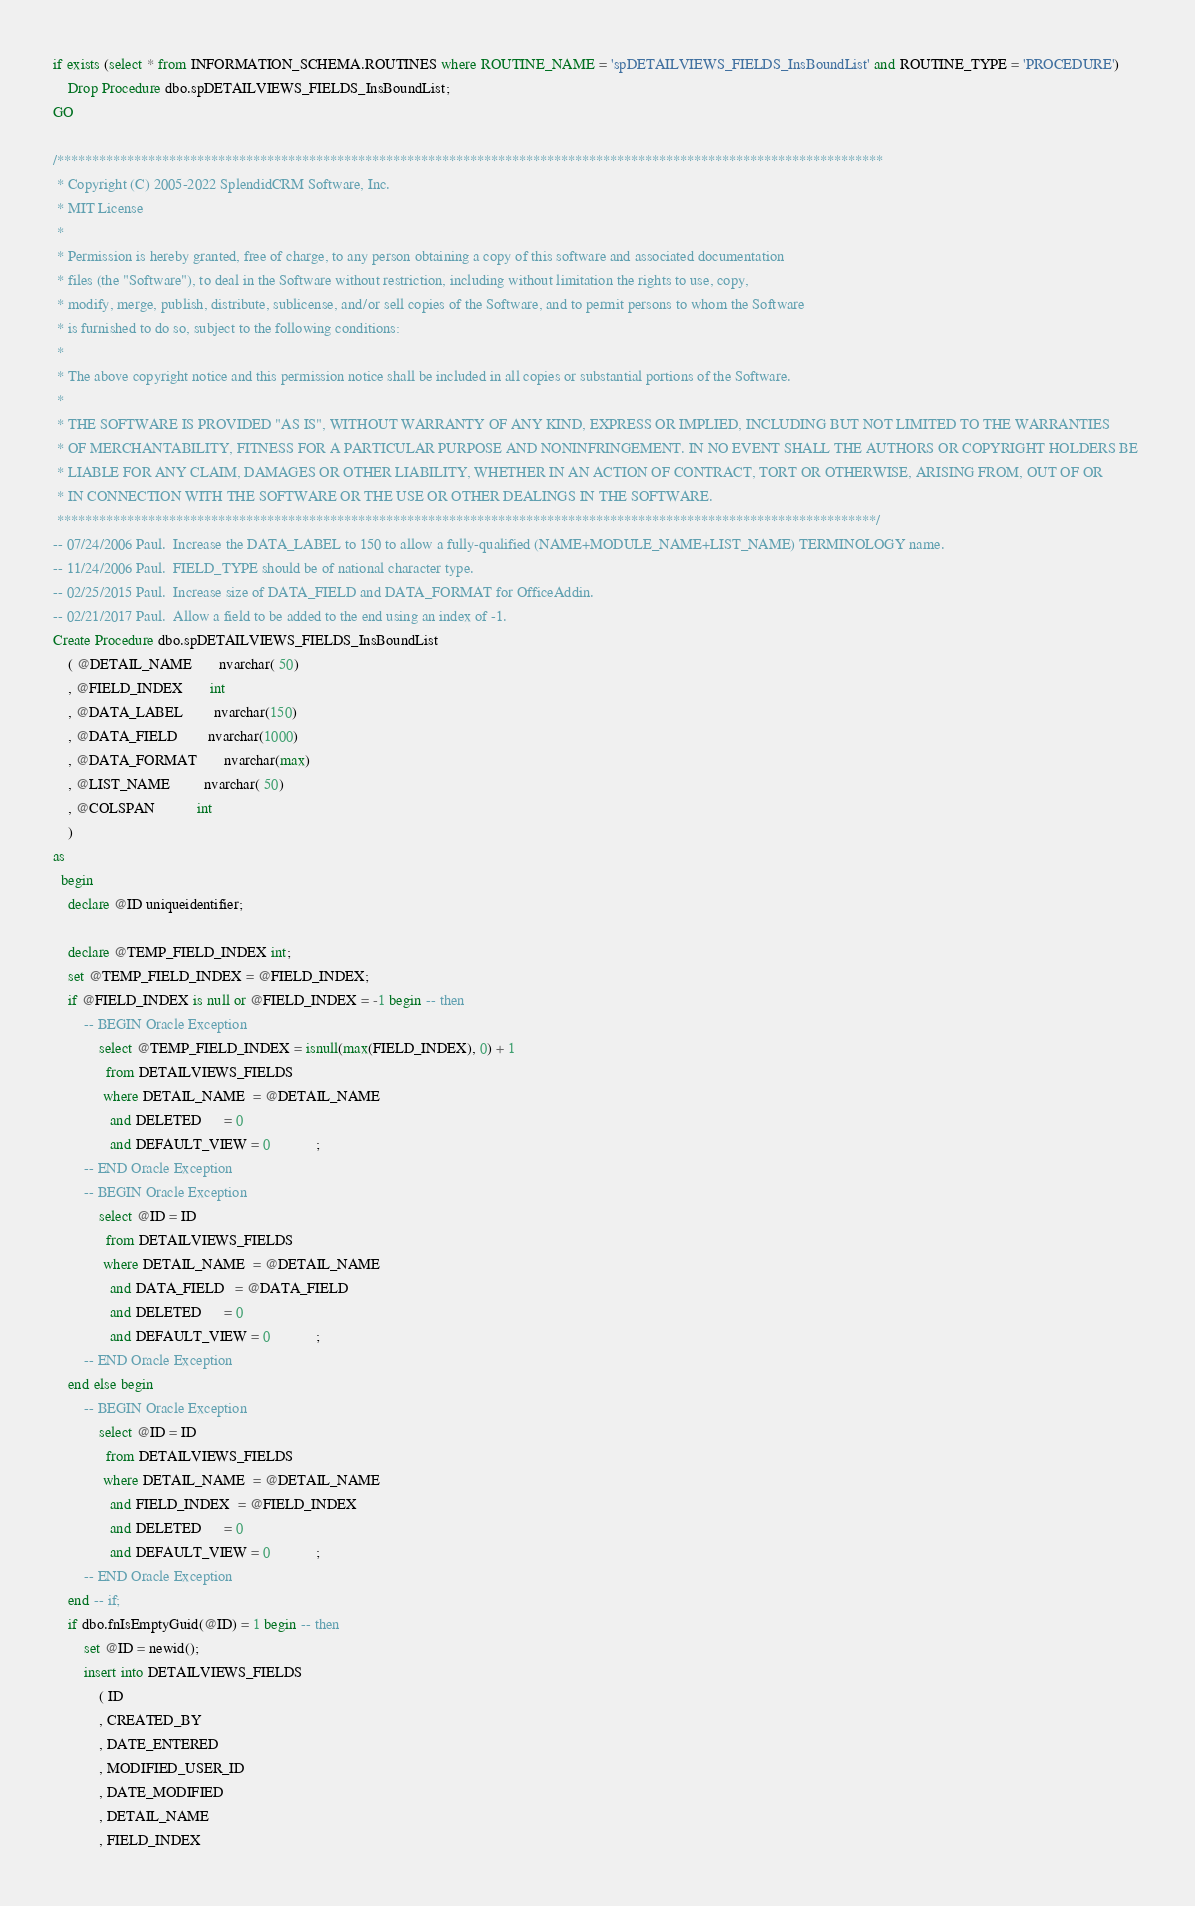<code> <loc_0><loc_0><loc_500><loc_500><_SQL_>if exists (select * from INFORMATION_SCHEMA.ROUTINES where ROUTINE_NAME = 'spDETAILVIEWS_FIELDS_InsBoundList' and ROUTINE_TYPE = 'PROCEDURE')
	Drop Procedure dbo.spDETAILVIEWS_FIELDS_InsBoundList;
GO
 
/**********************************************************************************************************************
 * Copyright (C) 2005-2022 SplendidCRM Software, Inc. 
 * MIT License
 * 
 * Permission is hereby granted, free of charge, to any person obtaining a copy of this software and associated documentation 
 * files (the "Software"), to deal in the Software without restriction, including without limitation the rights to use, copy, 
 * modify, merge, publish, distribute, sublicense, and/or sell copies of the Software, and to permit persons to whom the Software 
 * is furnished to do so, subject to the following conditions:
 * 
 * The above copyright notice and this permission notice shall be included in all copies or substantial portions of the Software.
 * 
 * THE SOFTWARE IS PROVIDED "AS IS", WITHOUT WARRANTY OF ANY KIND, EXPRESS OR IMPLIED, INCLUDING BUT NOT LIMITED TO THE WARRANTIES 
 * OF MERCHANTABILITY, FITNESS FOR A PARTICULAR PURPOSE AND NONINFRINGEMENT. IN NO EVENT SHALL THE AUTHORS OR COPYRIGHT HOLDERS BE 
 * LIABLE FOR ANY CLAIM, DAMAGES OR OTHER LIABILITY, WHETHER IN AN ACTION OF CONTRACT, TORT OR OTHERWISE, ARISING FROM, OUT OF OR 
 * IN CONNECTION WITH THE SOFTWARE OR THE USE OR OTHER DEALINGS IN THE SOFTWARE.
 *********************************************************************************************************************/
-- 07/24/2006 Paul.  Increase the DATA_LABEL to 150 to allow a fully-qualified (NAME+MODULE_NAME+LIST_NAME) TERMINOLOGY name. 
-- 11/24/2006 Paul.  FIELD_TYPE should be of national character type. 
-- 02/25/2015 Paul.  Increase size of DATA_FIELD and DATA_FORMAT for OfficeAddin. 
-- 02/21/2017 Paul.  Allow a field to be added to the end using an index of -1. 
Create Procedure dbo.spDETAILVIEWS_FIELDS_InsBoundList
	( @DETAIL_NAME       nvarchar( 50)
	, @FIELD_INDEX       int
	, @DATA_LABEL        nvarchar(150)
	, @DATA_FIELD        nvarchar(1000)
	, @DATA_FORMAT       nvarchar(max)
	, @LIST_NAME         nvarchar( 50)
	, @COLSPAN           int
	)
as
  begin
	declare @ID uniqueidentifier;
	
	declare @TEMP_FIELD_INDEX int;	
	set @TEMP_FIELD_INDEX = @FIELD_INDEX;
	if @FIELD_INDEX is null or @FIELD_INDEX = -1 begin -- then
		-- BEGIN Oracle Exception
			select @TEMP_FIELD_INDEX = isnull(max(FIELD_INDEX), 0) + 1
			  from DETAILVIEWS_FIELDS
			 where DETAIL_NAME  = @DETAIL_NAME
			   and DELETED      = 0            
			   and DEFAULT_VIEW = 0            ;
		-- END Oracle Exception
		-- BEGIN Oracle Exception
			select @ID = ID
			  from DETAILVIEWS_FIELDS
			 where DETAIL_NAME  = @DETAIL_NAME
			   and DATA_FIELD   = @DATA_FIELD
			   and DELETED      = 0            
			   and DEFAULT_VIEW = 0            ;
		-- END Oracle Exception
	end else begin
		-- BEGIN Oracle Exception
			select @ID = ID
			  from DETAILVIEWS_FIELDS
			 where DETAIL_NAME  = @DETAIL_NAME
			   and FIELD_INDEX  = @FIELD_INDEX
			   and DELETED      = 0            
			   and DEFAULT_VIEW = 0            ;
		-- END Oracle Exception
	end -- if;
	if dbo.fnIsEmptyGuid(@ID) = 1 begin -- then
		set @ID = newid();
		insert into DETAILVIEWS_FIELDS
			( ID               
			, CREATED_BY       
			, DATE_ENTERED     
			, MODIFIED_USER_ID 
			, DATE_MODIFIED    
			, DETAIL_NAME      
			, FIELD_INDEX      </code> 